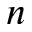<formula> <loc_0><loc_0><loc_500><loc_500>n</formula> 